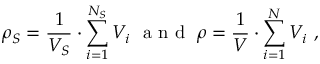Convert formula to latex. <formula><loc_0><loc_0><loc_500><loc_500>\rho _ { S } = \frac { 1 } { V _ { S } } \cdot \sum _ { i = 1 } ^ { N _ { S } } V _ { i } \ a n d \ \rho = \frac { 1 } { V } \cdot \sum _ { i = 1 } ^ { N } V _ { i } \ ,</formula> 